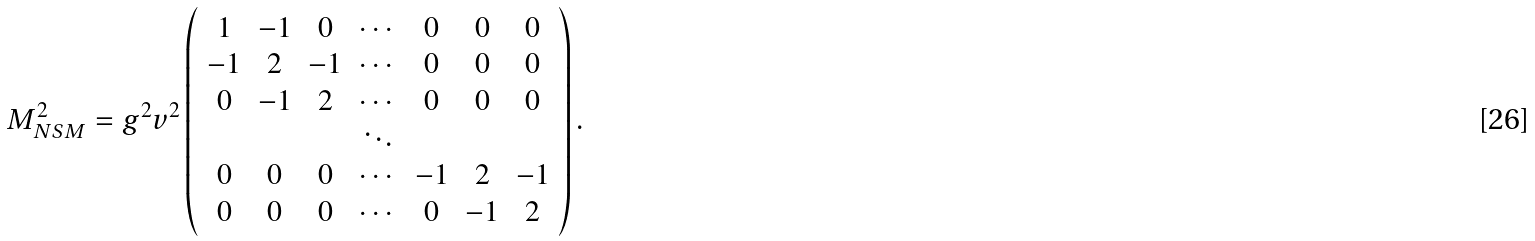<formula> <loc_0><loc_0><loc_500><loc_500>M _ { N S M } ^ { 2 } = g ^ { 2 } v ^ { 2 } \left ( \begin{array} { c c c c c c c } 1 & - 1 & 0 & \cdots & 0 & 0 & 0 \\ - 1 & 2 & - 1 & \cdots & 0 & 0 & 0 \\ 0 & - 1 & 2 & \cdots & 0 & 0 & 0 \\ & & & \ddots & & & \\ 0 & 0 & 0 & \cdots & - 1 & 2 & - 1 \\ 0 & 0 & 0 & \cdots & 0 & - 1 & 2 \end{array} \right ) .</formula> 